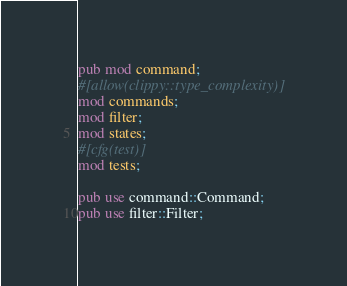Convert code to text. <code><loc_0><loc_0><loc_500><loc_500><_Rust_>pub mod command;
#[allow(clippy::type_complexity)]
mod commands;
mod filter;
mod states;
#[cfg(test)]
mod tests;

pub use command::Command;
pub use filter::Filter;
</code> 